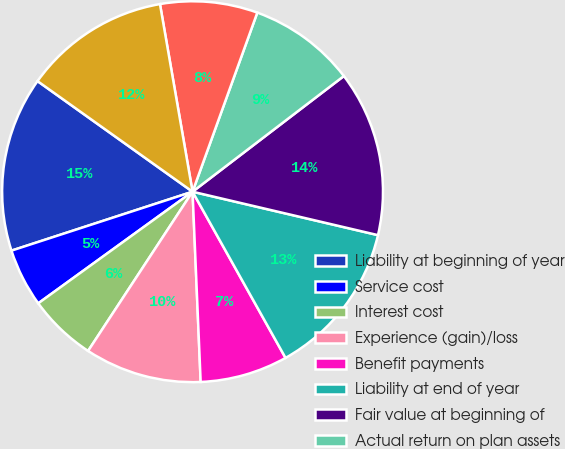<chart> <loc_0><loc_0><loc_500><loc_500><pie_chart><fcel>Liability at beginning of year<fcel>Service cost<fcel>Interest cost<fcel>Experience (gain)/loss<fcel>Benefit payments<fcel>Liability at end of year<fcel>Fair value at beginning of<fcel>Actual return on plan assets<fcel>Employer contributions/funding<fcel>Fair value at end of year<nl><fcel>14.87%<fcel>4.96%<fcel>5.79%<fcel>9.92%<fcel>7.44%<fcel>13.22%<fcel>14.05%<fcel>9.09%<fcel>8.26%<fcel>12.4%<nl></chart> 